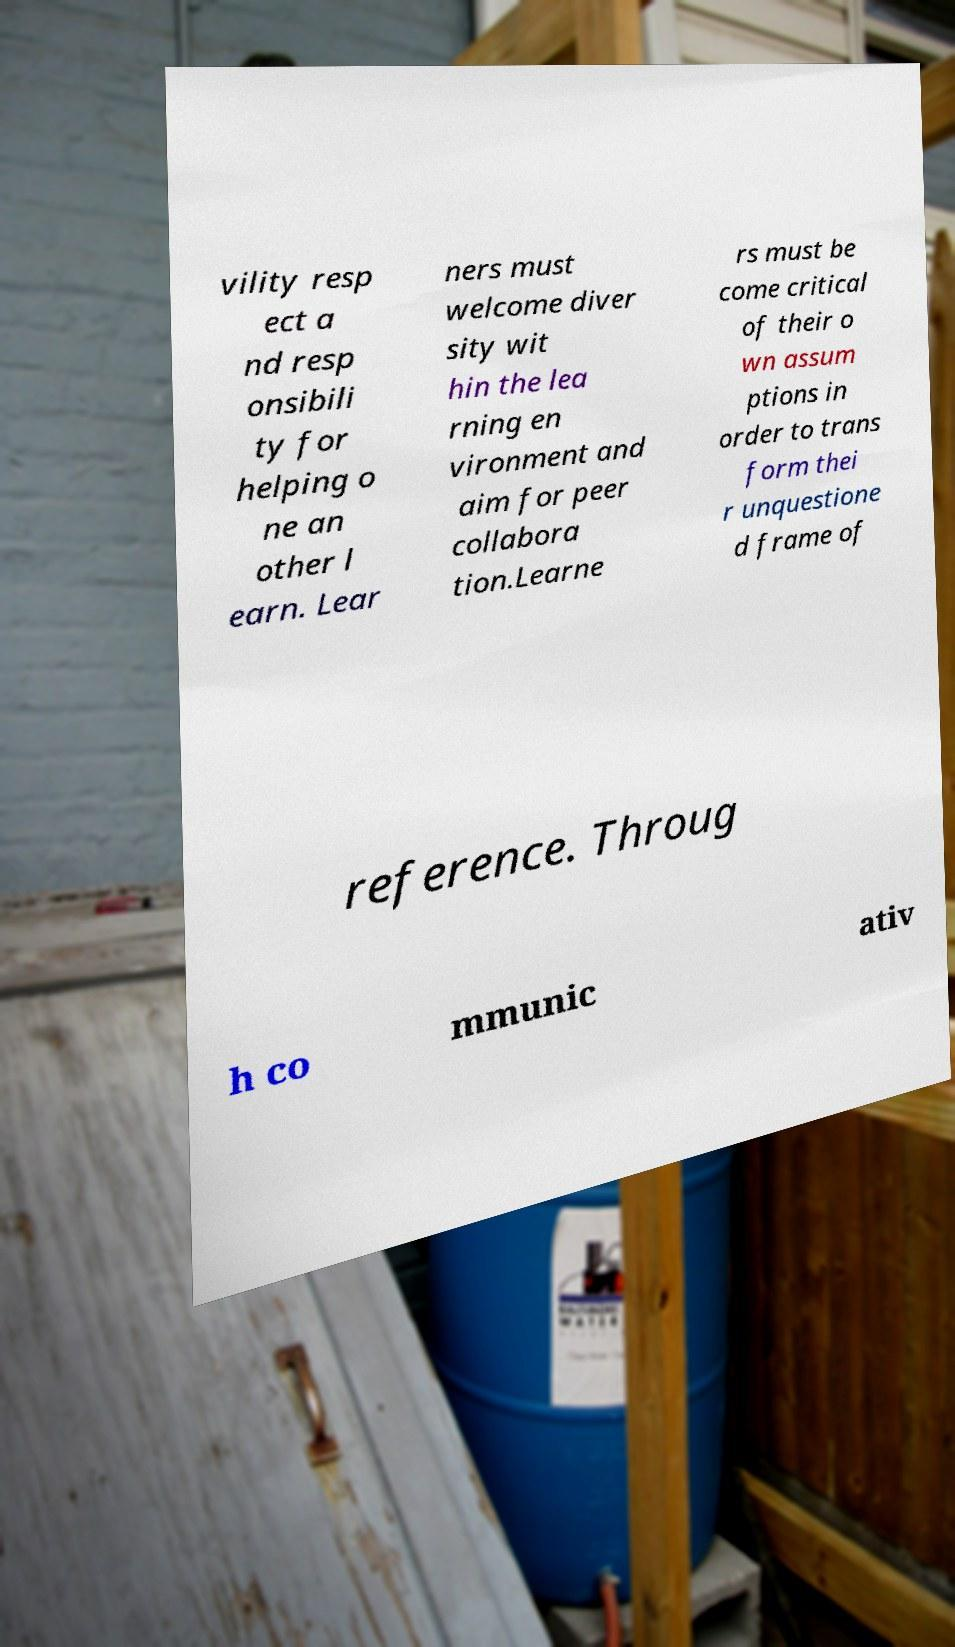There's text embedded in this image that I need extracted. Can you transcribe it verbatim? vility resp ect a nd resp onsibili ty for helping o ne an other l earn. Lear ners must welcome diver sity wit hin the lea rning en vironment and aim for peer collabora tion.Learne rs must be come critical of their o wn assum ptions in order to trans form thei r unquestione d frame of reference. Throug h co mmunic ativ 